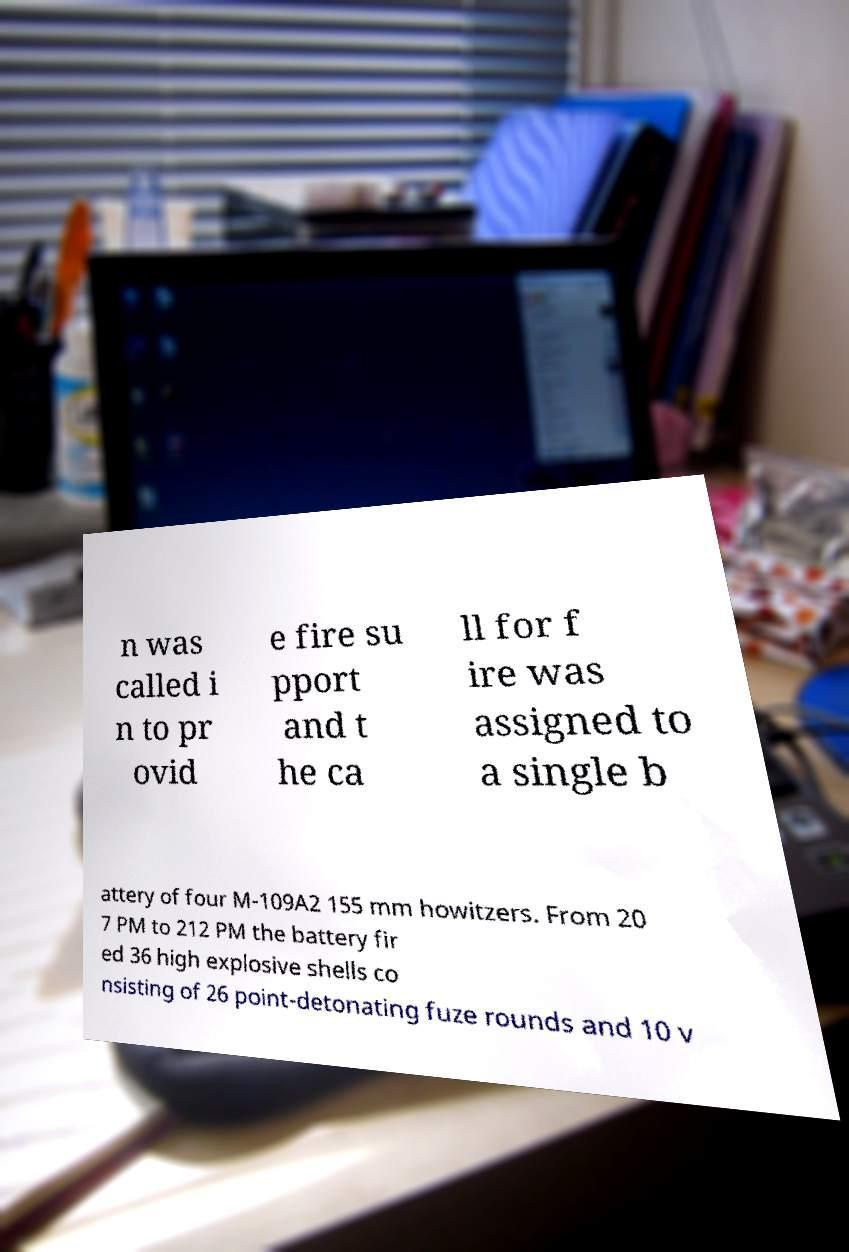Could you extract and type out the text from this image? n was called i n to pr ovid e fire su pport and t he ca ll for f ire was assigned to a single b attery of four M-109A2 155 mm howitzers. From 20 7 PM to 212 PM the battery fir ed 36 high explosive shells co nsisting of 26 point-detonating fuze rounds and 10 v 